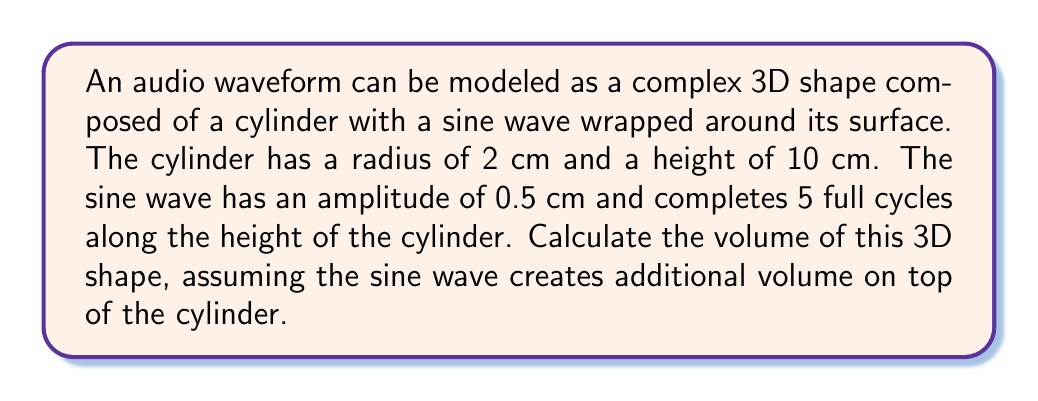Show me your answer to this math problem. To solve this problem, we'll follow these steps:

1. Calculate the volume of the cylinder:
   $$V_{cylinder} = \pi r^2 h$$
   where $r$ is the radius and $h$ is the height.
   $$V_{cylinder} = \pi (2\text{ cm})^2 (10\text{ cm}) = 40\pi\text{ cm}^3$$

2. Calculate the volume added by the sine wave:
   The sine wave can be thought of as a thin strip wrapped around the cylinder.
   Its length is the circumference of the cylinder: $2\pi r = 4\pi\text{ cm}$
   Its width is the height of the cylinder: $10\text{ cm}$
   Its average thickness is half the amplitude: $0.25\text{ cm}$

   $$V_{wave} = 4\pi\text{ cm} \cdot 10\text{ cm} \cdot 0.25\text{ cm} = 10\pi\text{ cm}^3$$

3. Sum the volumes:
   $$V_{total} = V_{cylinder} + V_{wave} = 40\pi\text{ cm}^3 + 10\pi\text{ cm}^3 = 50\pi\text{ cm}^3$$

4. Simplify:
   $$V_{total} = 50\pi\text{ cm}^3 \approx 157.08\text{ cm}^3$$
Answer: $50\pi\text{ cm}^3$ or approximately $157.08\text{ cm}^3$ 